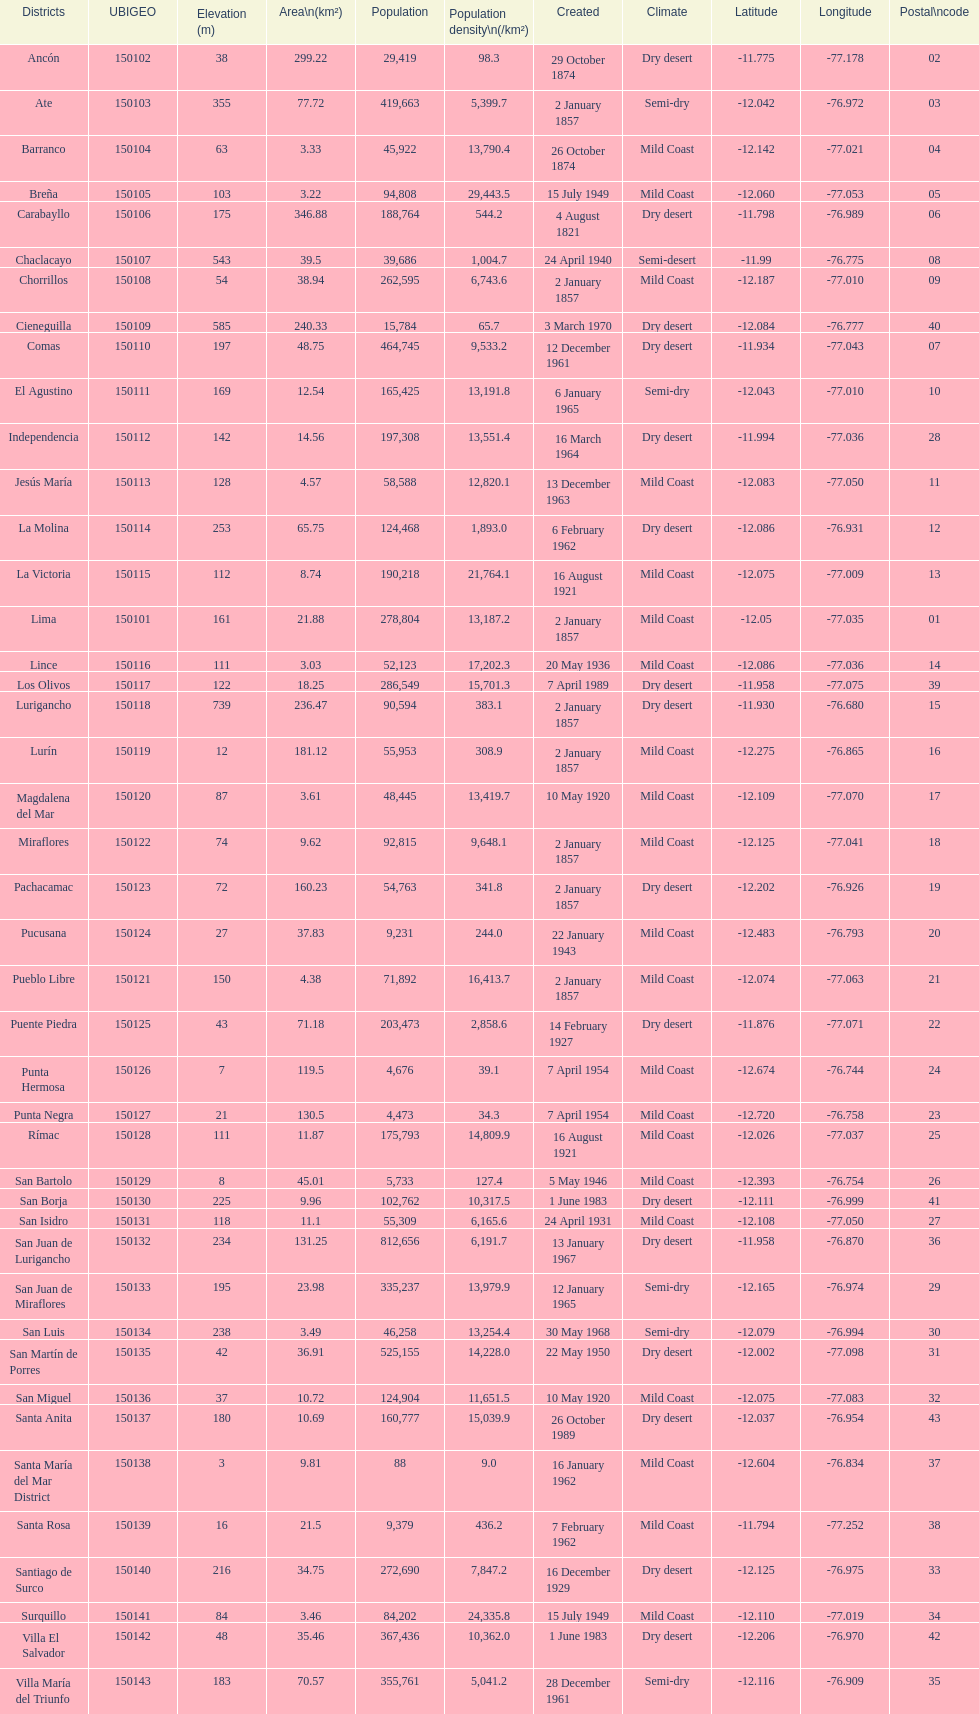What was the last district created? Santa Anita. 